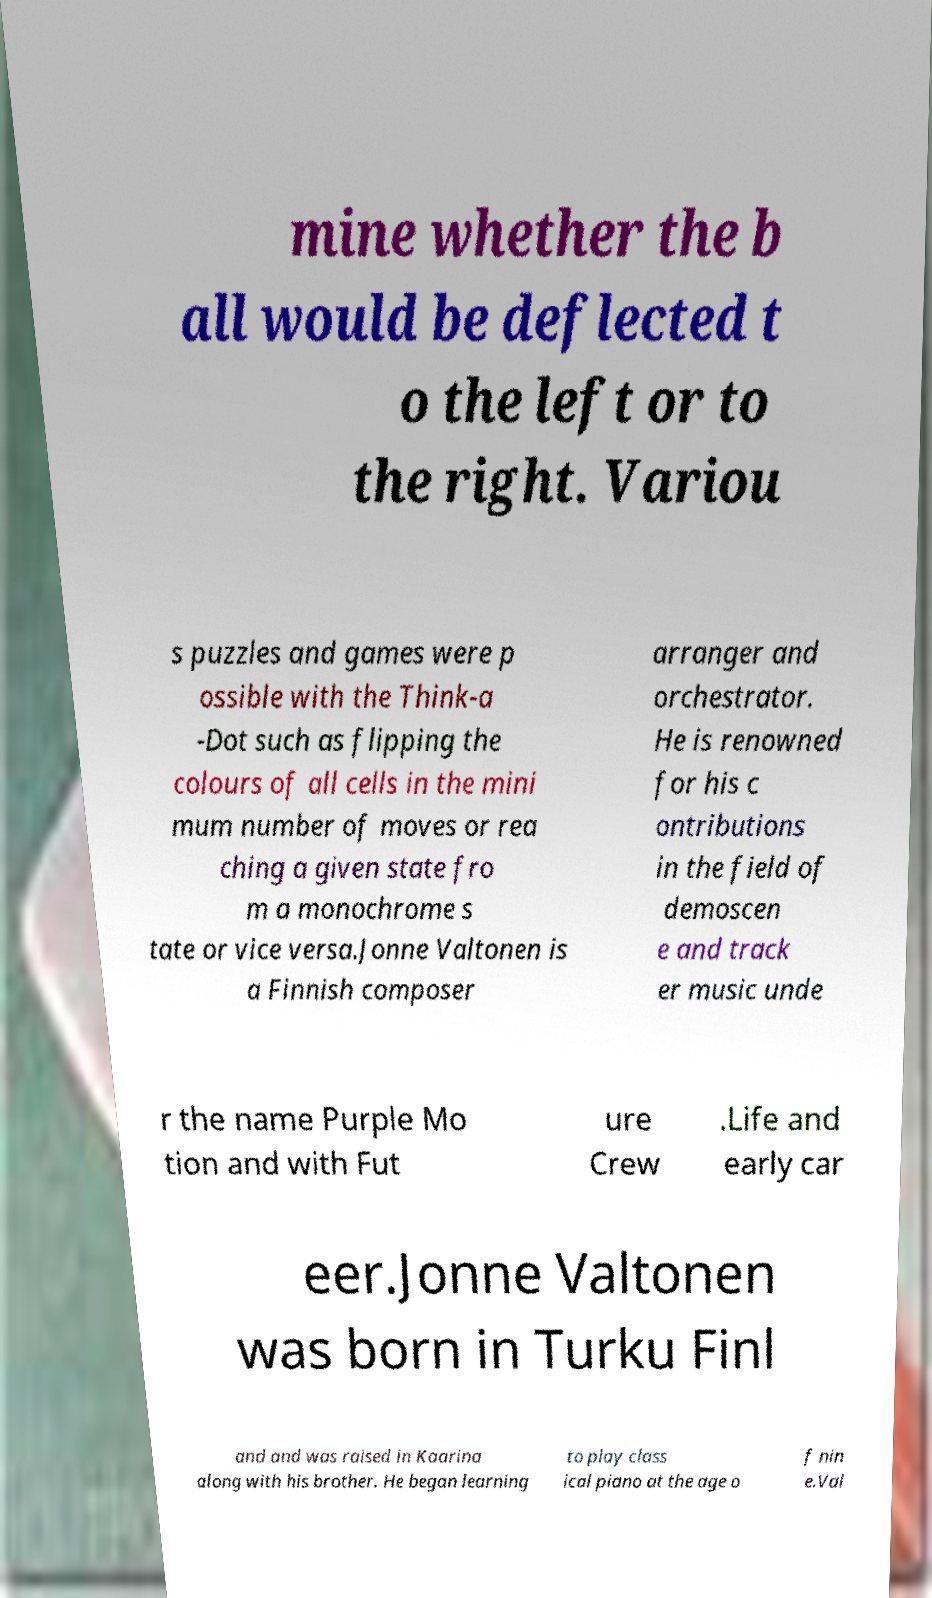Could you assist in decoding the text presented in this image and type it out clearly? mine whether the b all would be deflected t o the left or to the right. Variou s puzzles and games were p ossible with the Think-a -Dot such as flipping the colours of all cells in the mini mum number of moves or rea ching a given state fro m a monochrome s tate or vice versa.Jonne Valtonen is a Finnish composer arranger and orchestrator. He is renowned for his c ontributions in the field of demoscen e and track er music unde r the name Purple Mo tion and with Fut ure Crew .Life and early car eer.Jonne Valtonen was born in Turku Finl and and was raised in Kaarina along with his brother. He began learning to play class ical piano at the age o f nin e.Val 